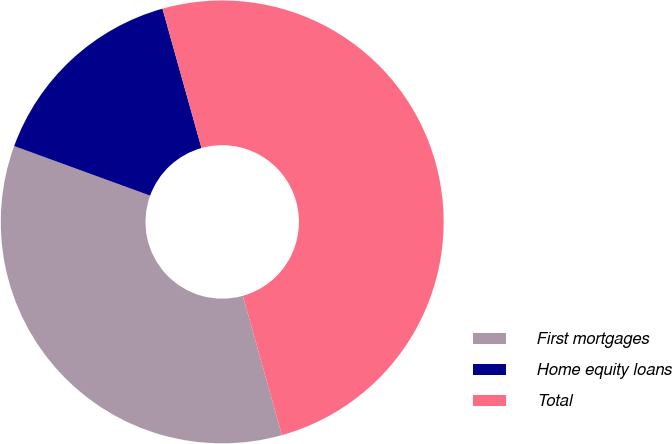Convert chart. <chart><loc_0><loc_0><loc_500><loc_500><pie_chart><fcel>First mortgages<fcel>Home equity loans<fcel>Total<nl><fcel>34.91%<fcel>15.09%<fcel>50.0%<nl></chart> 